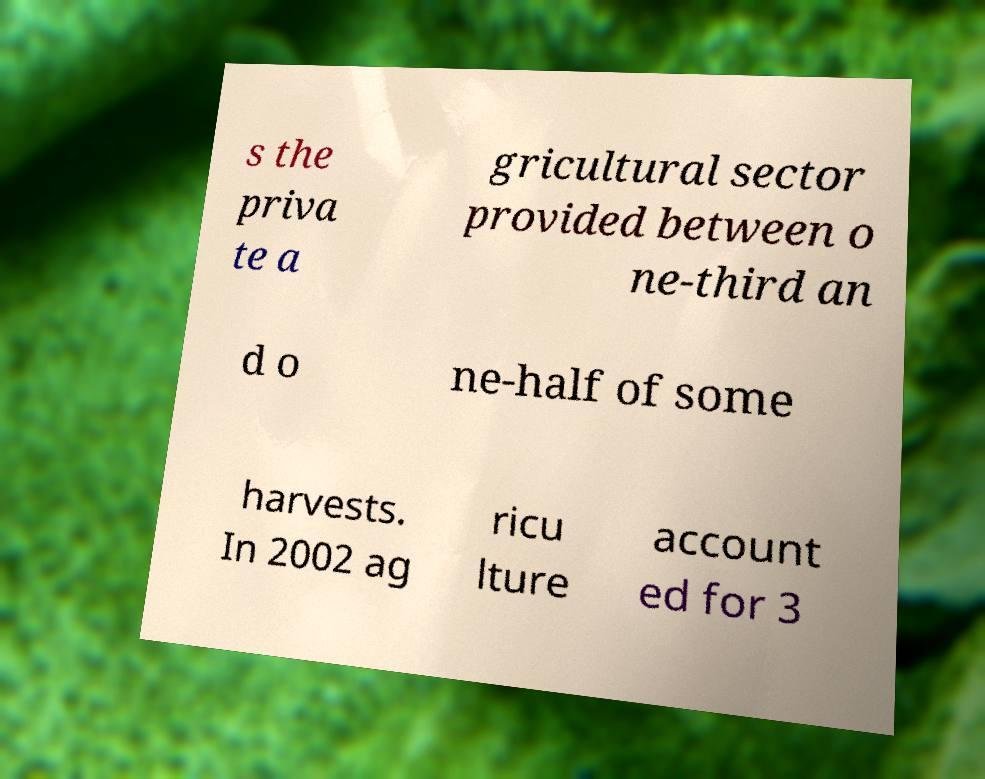For documentation purposes, I need the text within this image transcribed. Could you provide that? s the priva te a gricultural sector provided between o ne-third an d o ne-half of some harvests. In 2002 ag ricu lture account ed for 3 